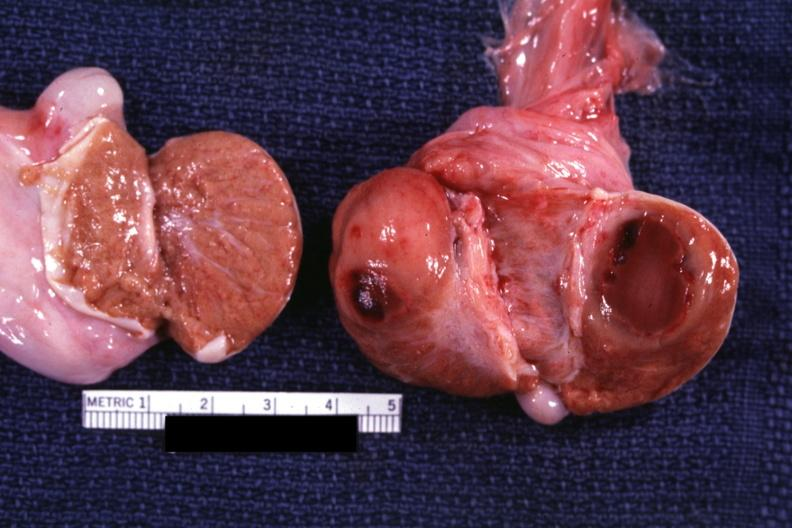what is present?
Answer the question using a single word or phrase. Leukemic infiltrate with necrosis 